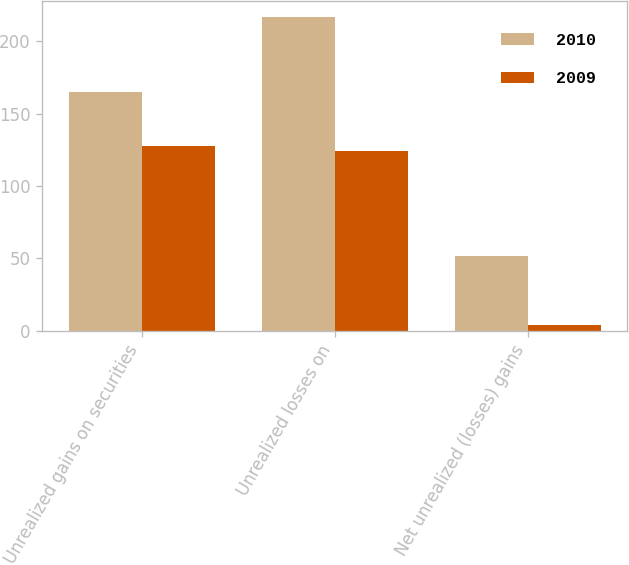Convert chart. <chart><loc_0><loc_0><loc_500><loc_500><stacked_bar_chart><ecel><fcel>Unrealized gains on securities<fcel>Unrealized losses on<fcel>Net unrealized (losses) gains<nl><fcel>2010<fcel>165<fcel>217<fcel>52<nl><fcel>2009<fcel>128<fcel>124<fcel>4<nl></chart> 